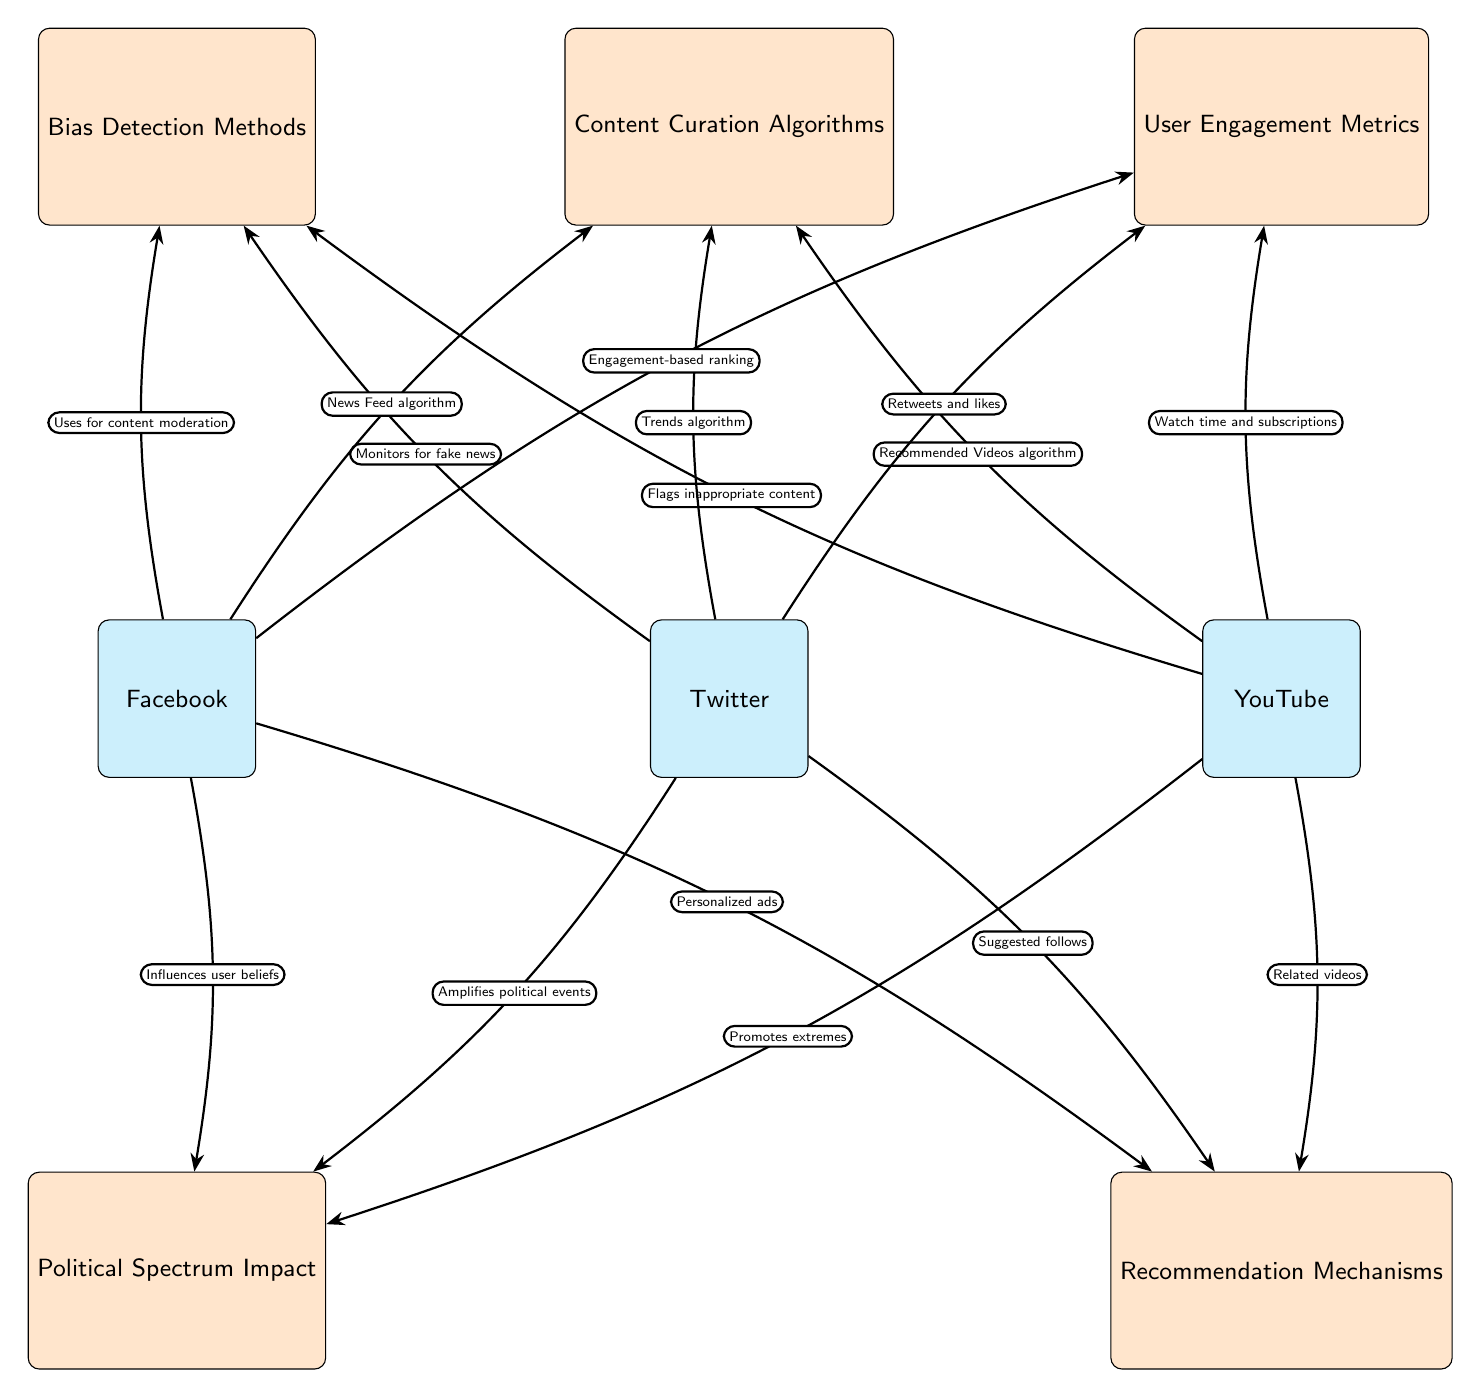What are the three social media platforms represented in the diagram? The diagram includes Facebook, Twitter, and YouTube as the three platforms represented by the nodes on the horizontal axis.
Answer: Facebook, Twitter, YouTube How many concepts are linked to Facebook in the diagram? Facebook is connected to four concepts: Bias Detection Methods, Content Curation Algorithms, User Engagement Metrics, and Political Spectrum Impact along with Recommendation Mechanisms.
Answer: 4 Which algorithm is associated with Twitter's content curation? The diagram states that Twitter's content curation algorithm is the Trends algorithm, which is clearly labeled in the relevant edge connecting Twitter to the concept node for Content Curation Algorithms.
Answer: Trends algorithm What kind of bias does Facebook's bias detection methods address? Facebook uses bias detection methods primarily for content moderation purposes, as indicated by the edge label connecting Facebook to the concept Bias Detection Methods.
Answer: Content moderation What is the impact of YouTube’s recommendation mechanisms on the political spectrum? According to the diagram, YouTube’s recommendation mechanisms promote extremes on the political spectrum, as denoted by the edge that connects YouTube to the Political Spectrum Impact concept.
Answer: Promotes extremes How many connections does the YouTube node have in total? The YouTube node has a total of four connections: one to Bias Detection Methods, one to Content Curation Algorithms, one to User Engagement Metrics, and one to Recommendation Mechanisms.
Answer: 4 Which platform has an edge labeled "Influences user beliefs"? The diagram indicates that the edge labeled "Influences user beliefs" is associated with the Facebook node, connecting it to the concept Political Spectrum Impact.
Answer: Facebook What is the basis for YouTube's user engagement metrics? YouTube's user engagement metrics are based on watch time and subscriptions, as shown by the edge label connecting YouTube to the User Engagement Metrics concept.
Answer: Watch time and subscriptions 